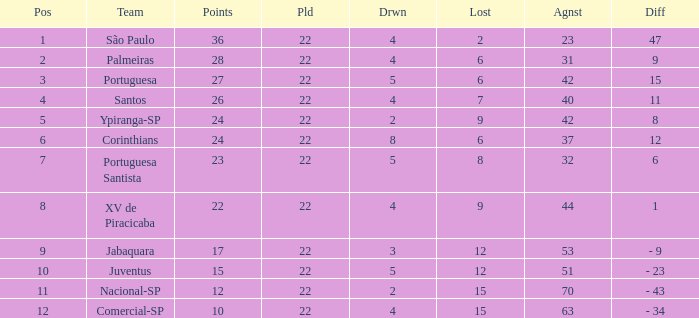Which Played has a Lost larger than 9, and a Points smaller than 15, and a Position smaller than 12, and a Drawn smaller than 2? None. 